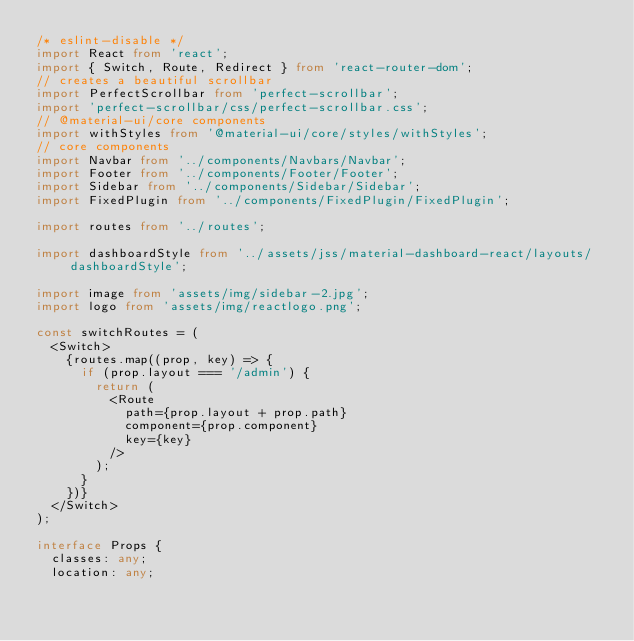Convert code to text. <code><loc_0><loc_0><loc_500><loc_500><_TypeScript_>/* eslint-disable */
import React from 'react';
import { Switch, Route, Redirect } from 'react-router-dom';
// creates a beautiful scrollbar
import PerfectScrollbar from 'perfect-scrollbar';
import 'perfect-scrollbar/css/perfect-scrollbar.css';
// @material-ui/core components
import withStyles from '@material-ui/core/styles/withStyles';
// core components
import Navbar from '../components/Navbars/Navbar';
import Footer from '../components/Footer/Footer';
import Sidebar from '../components/Sidebar/Sidebar';
import FixedPlugin from '../components/FixedPlugin/FixedPlugin';

import routes from '../routes';

import dashboardStyle from '../assets/jss/material-dashboard-react/layouts/dashboardStyle';

import image from 'assets/img/sidebar-2.jpg';
import logo from 'assets/img/reactlogo.png';

const switchRoutes = (
  <Switch>
    {routes.map((prop, key) => {
      if (prop.layout === '/admin') {
        return (
          <Route
            path={prop.layout + prop.path}
            component={prop.component}
            key={key}
          />
        );
      }
    })}
  </Switch>
);

interface Props {
  classes: any;
  location: any;</code> 